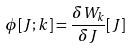Convert formula to latex. <formula><loc_0><loc_0><loc_500><loc_500>\phi [ J ; k ] = \frac { \delta W _ { k } } { \delta J } [ J ]</formula> 